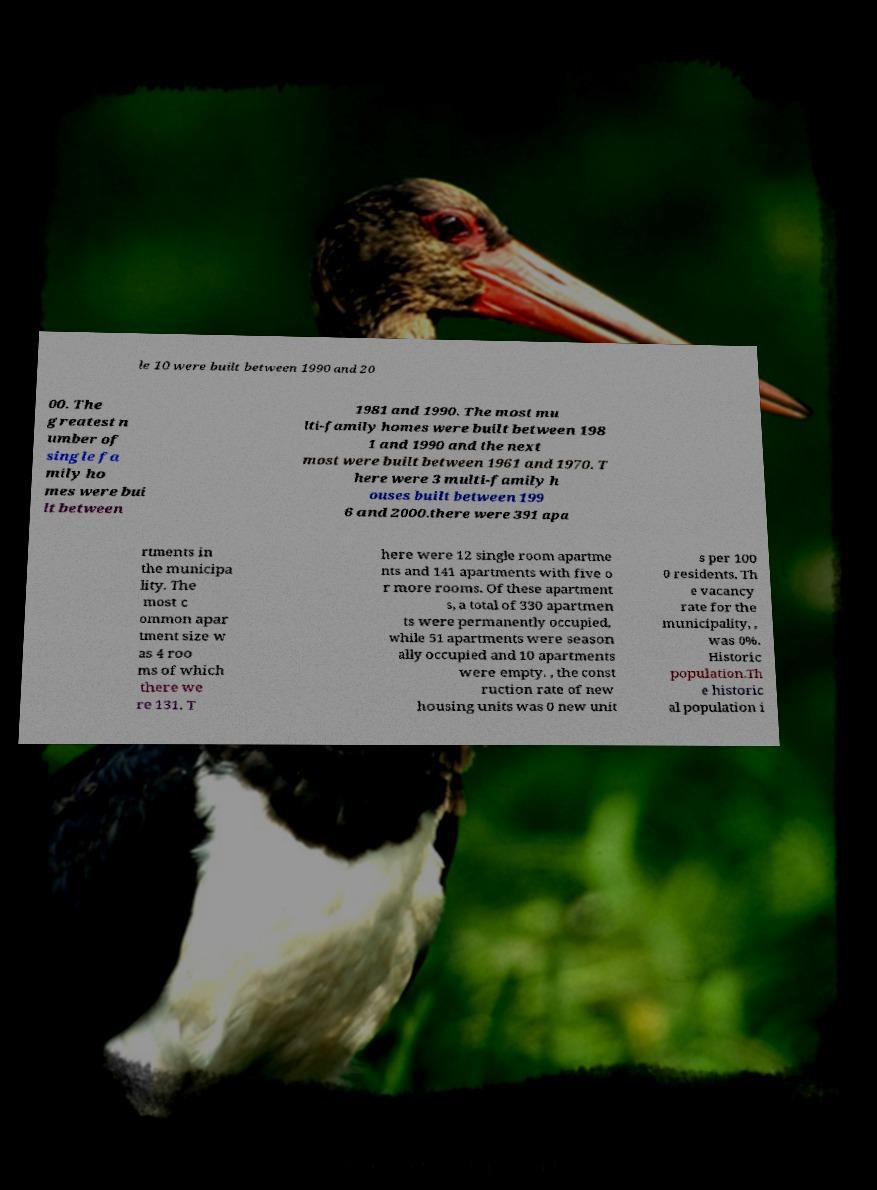Please read and relay the text visible in this image. What does it say? le 10 were built between 1990 and 20 00. The greatest n umber of single fa mily ho mes were bui lt between 1981 and 1990. The most mu lti-family homes were built between 198 1 and 1990 and the next most were built between 1961 and 1970. T here were 3 multi-family h ouses built between 199 6 and 2000.there were 391 apa rtments in the municipa lity. The most c ommon apar tment size w as 4 roo ms of which there we re 131. T here were 12 single room apartme nts and 141 apartments with five o r more rooms. Of these apartment s, a total of 330 apartmen ts were permanently occupied, while 51 apartments were season ally occupied and 10 apartments were empty. , the const ruction rate of new housing units was 0 new unit s per 100 0 residents. Th e vacancy rate for the municipality, , was 0%. Historic population.Th e historic al population i 